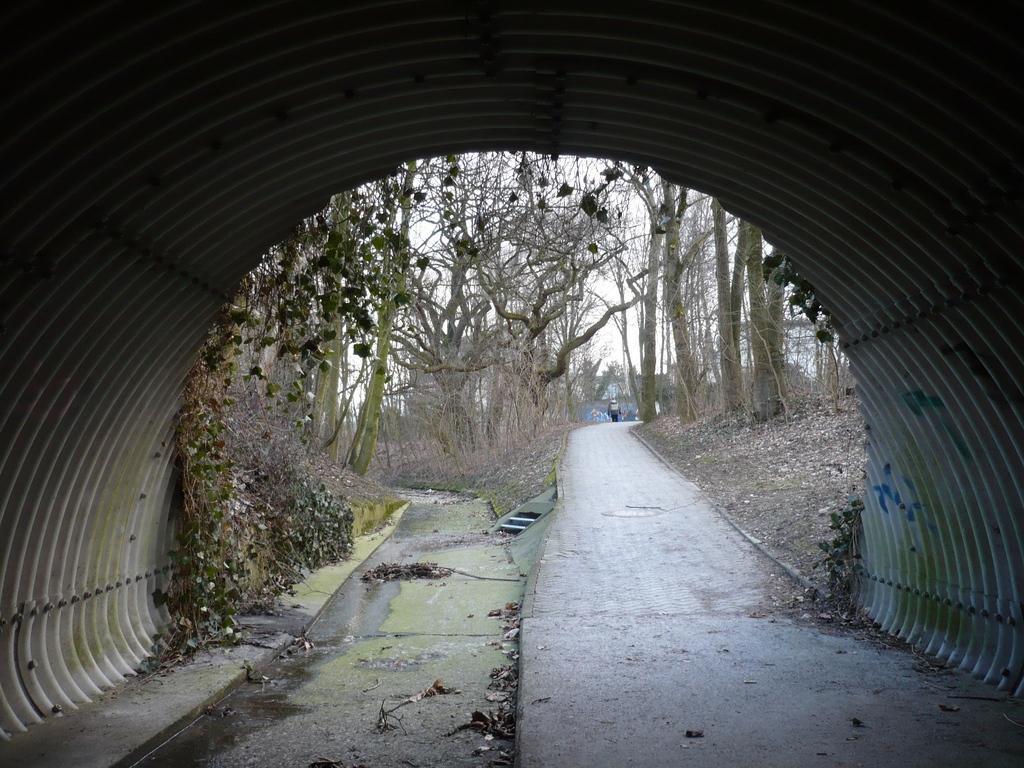Describe this image in one or two sentences. In this image we can see a tunnel, road, water, trees, dry leaves, a person moving on the road and the sky in the background. 